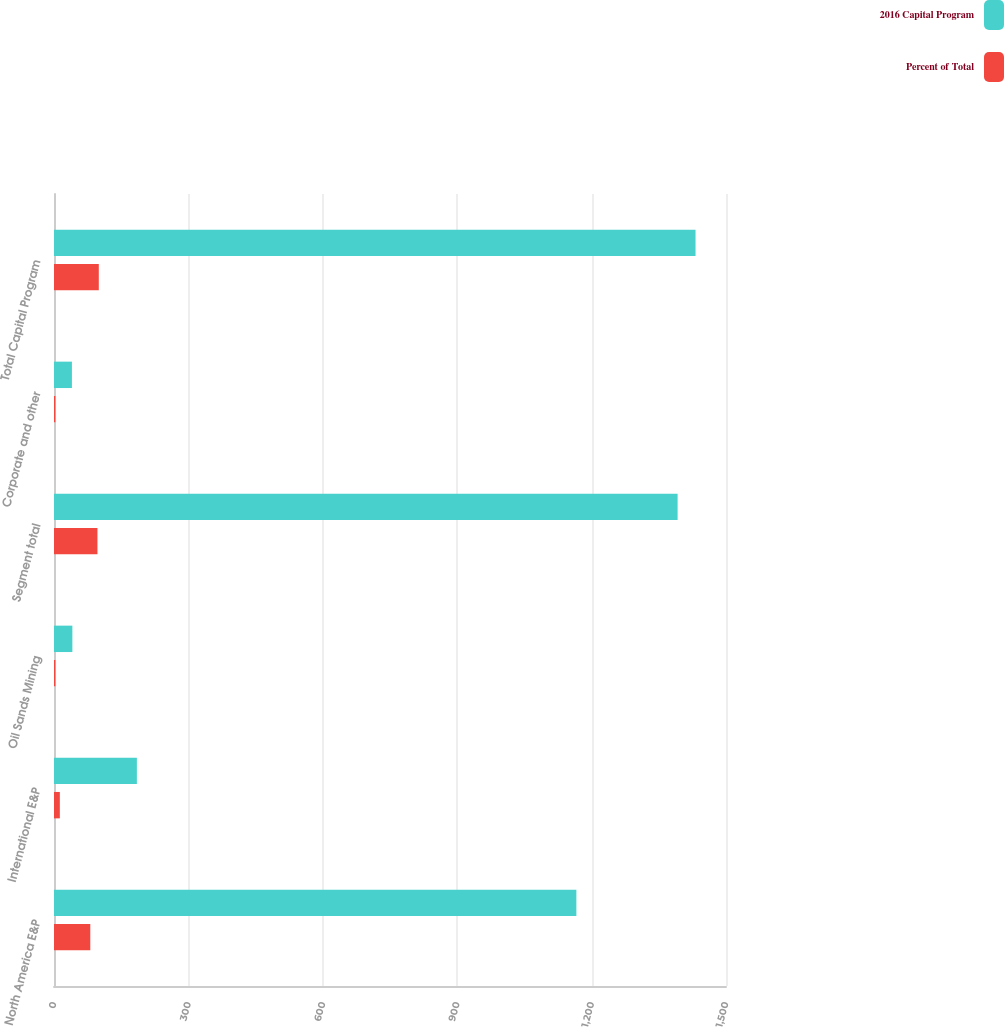Convert chart. <chart><loc_0><loc_0><loc_500><loc_500><stacked_bar_chart><ecel><fcel>North America E&P<fcel>International E&P<fcel>Oil Sands Mining<fcel>Segment total<fcel>Corporate and other<fcel>Total Capital Program<nl><fcel>2016 Capital Program<fcel>1166<fcel>185<fcel>41<fcel>1392<fcel>40<fcel>1432<nl><fcel>Percent of Total<fcel>81<fcel>13<fcel>3<fcel>97<fcel>3<fcel>100<nl></chart> 